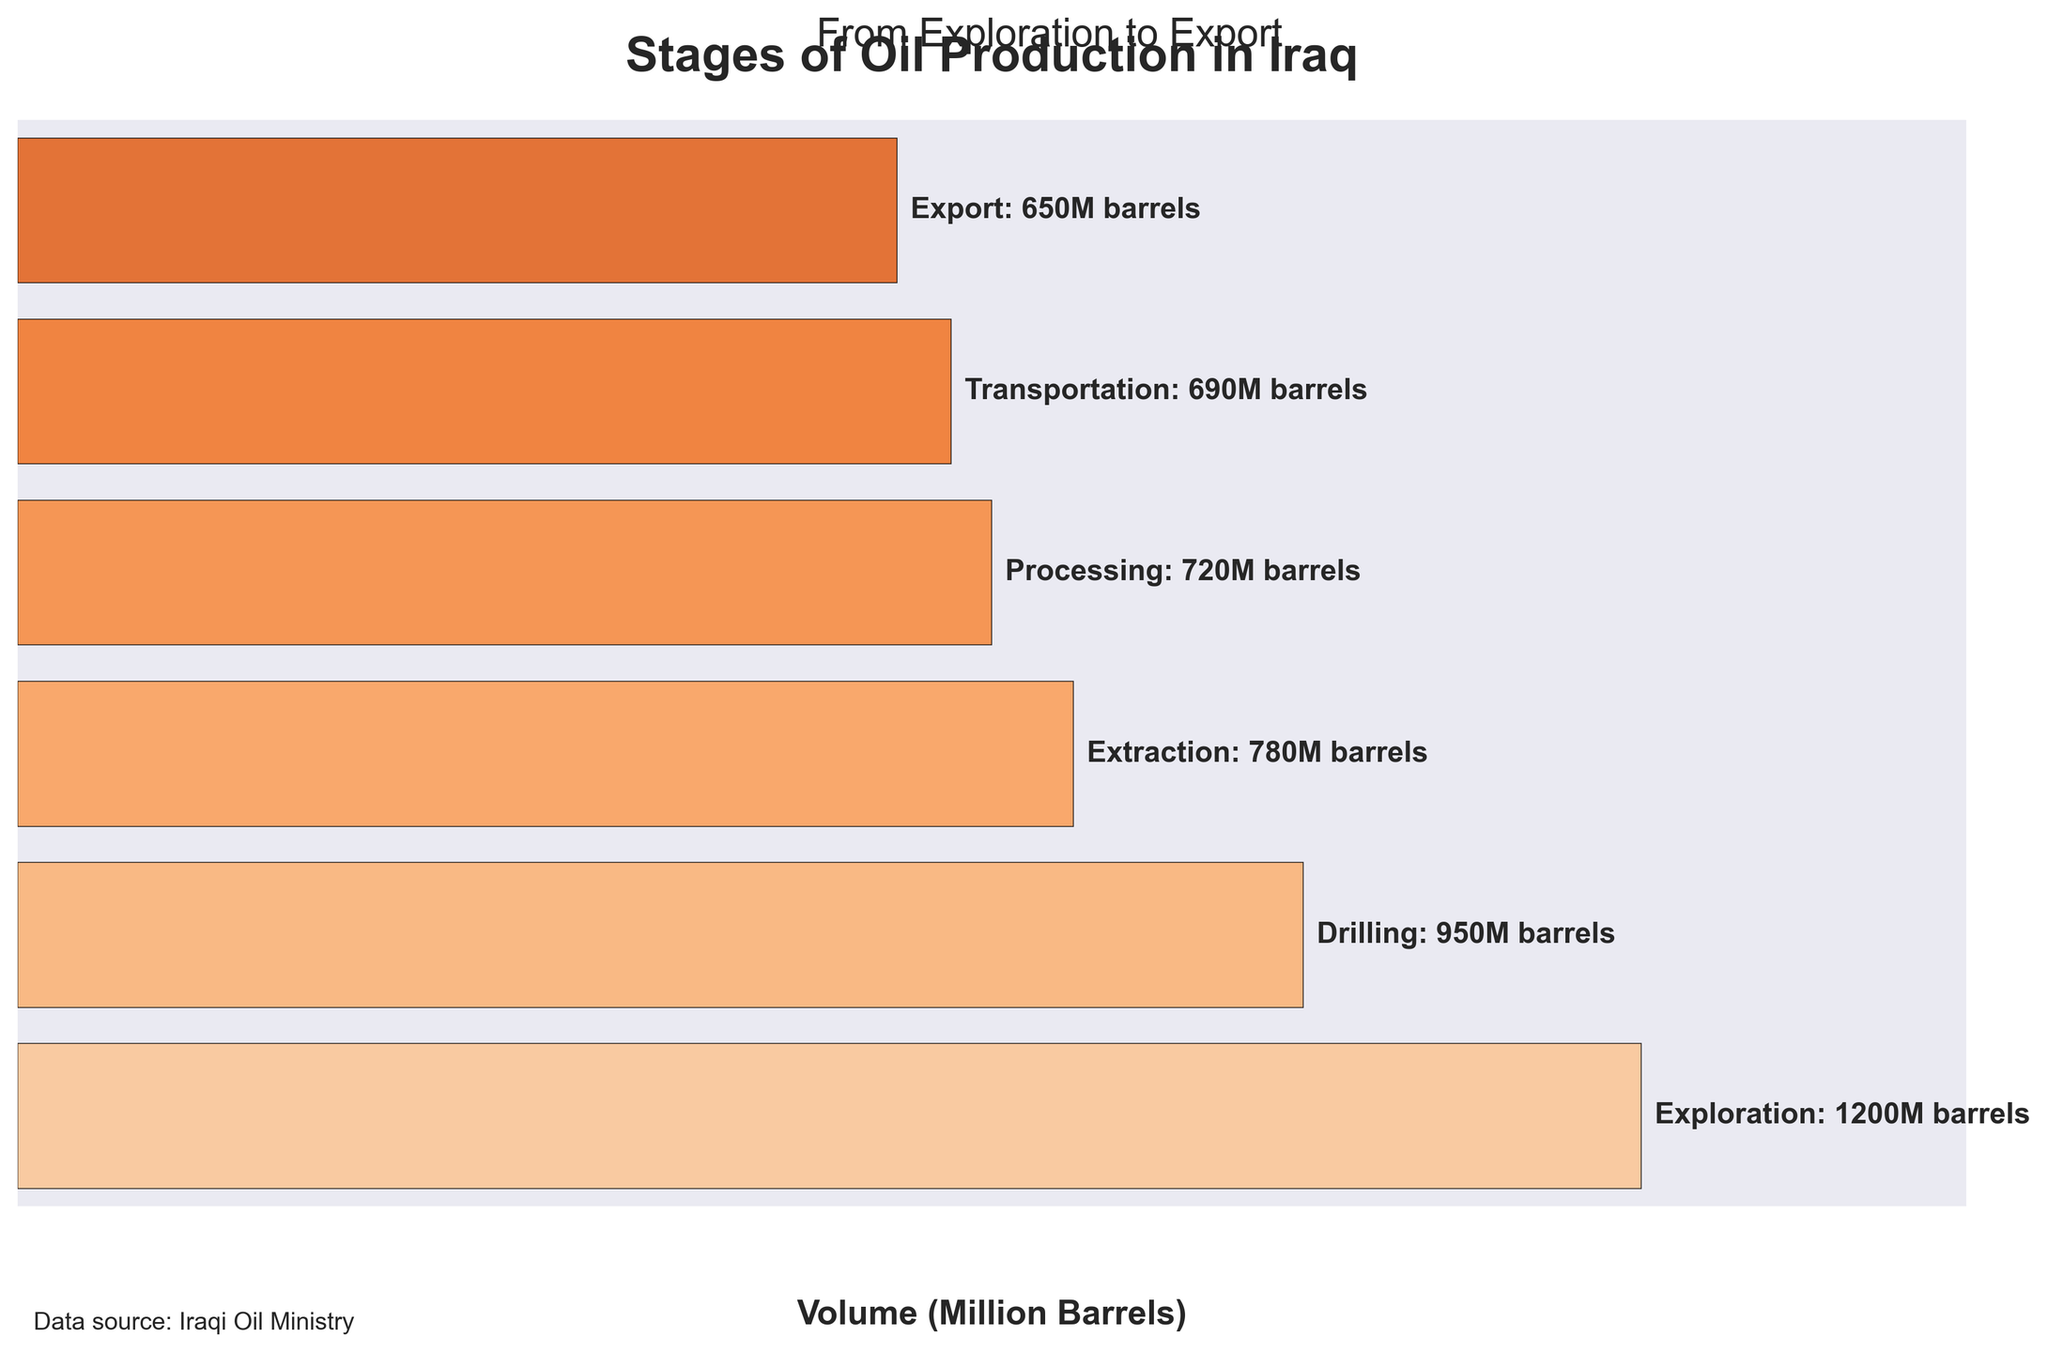What is the title of the figure? The title is located at the top center of the figure, and it reads "Stages of Oil Production in Iraq".
Answer: Stages of Oil Production in Iraq What is the volume of oil barrels at the 'Exploration' stage? The text annotation near the 'Exploration' stage indicates the volume, which is 1200 million barrels.
Answer: 1200 million barrels What is the volume difference between the 'Exploration' and 'Drilling' stages? Subtract the volume of the 'Drilling' stage from the volume of the 'Exploration' stage: 1200 - 950 = 250
Answer: 250 million barrels Which stage in the oil production process has the lowest volume? By looking at the volume annotations for each stage, 'Export' has the lowest volume of 650 million barrels.
Answer: Export How many million barrels are lost from 'Processing' to 'Export'? Subtract the volume of the 'Export' stage from the volume of the 'Processing' stage: 720 - 650 = 70
Answer: 70 million barrels What is the average volume of oil barrels from 'Exploration' to 'Export'? Sum all the volumes and divide by the number of stages: (1200 + 950 + 780 + 720 + 690 + 650) / 6 = 4980 / 6 = 830
Answer: 830 million barrels Which has a higher volume, 'Extraction' or 'Transportation'? Compare the volumes, 'Extraction' has 780 million barrels while 'Transportation' has 690 million barrels, so 'Extraction' has a higher volume.
Answer: Extraction What is the cumulative volume from 'Drilling' to 'Processing' stages? Sum the volumes from 'Drilling', 'Extraction', and 'Processing': 950 + 780 + 720 = 2450
Answer: 2450 million barrels How much oil is processed compared to the amount transported? The volume of the 'Processing' stage is 720 million barrels and the 'Transportation' stage is 690 million barrels. Calculation: 720 - 690 = 30
Answer: 30 million barrels What percentage of the oil explored is eventually exported? Calculate the ratio of 'Export' volume to 'Exploration' volume and multiply by 100: (650 / 1200) * 100 = 54.17%
Answer: 54.17% 